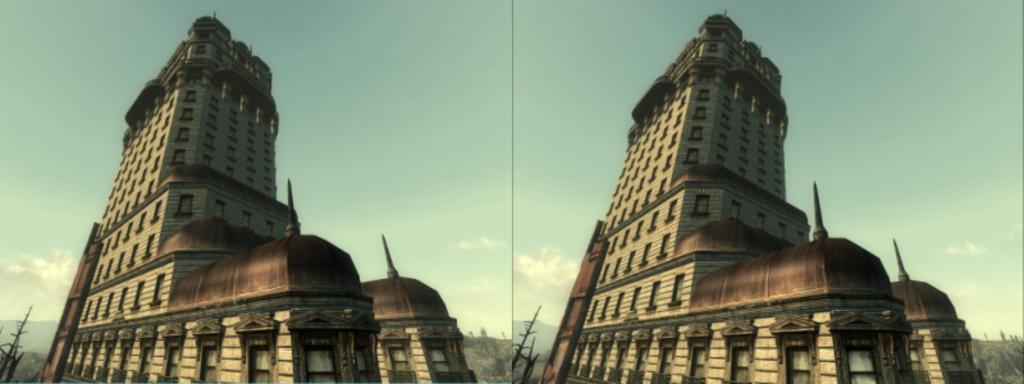Please provide a concise description of this image. This is a collage image and we can see buildings. 